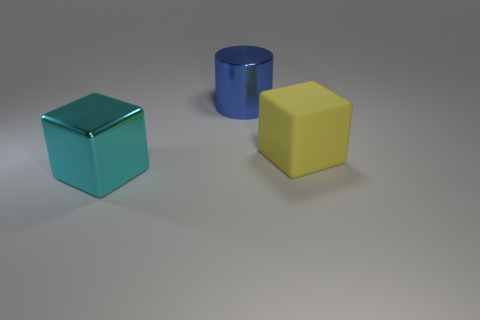What materials do the objects in this image look like they are made of? The objects in the image seem to have a smooth, matte finish. The blue and yellow objects resemble cubes potentially made out of colored rubber or a plastic with a rubber-like texture, while the cylinder has a glossy finish that suggests it might be made of metal or polished plastic. 